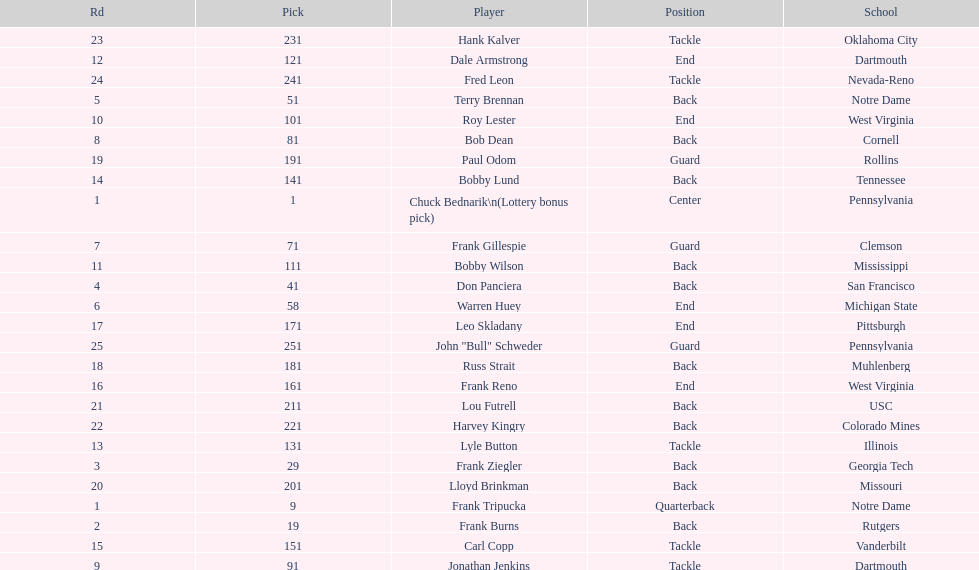Was chuck bednarik or frank tripucka the first draft pick? Chuck Bednarik. 